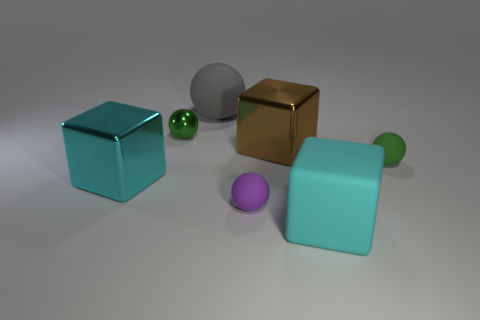There is another cyan thing that is the same shape as the big cyan matte thing; what material is it?
Make the answer very short. Metal. Is the shape of the cyan metallic thing the same as the gray object?
Ensure brevity in your answer.  No. Is there a tiny blue sphere that has the same material as the large brown block?
Ensure brevity in your answer.  No. Are there any big gray balls that are in front of the tiny rubber ball that is in front of the green matte thing?
Provide a succinct answer. No. There is a brown metal block to the right of the metallic ball; does it have the same size as the tiny metal sphere?
Give a very brief answer. No. What size is the green metallic thing?
Offer a very short reply. Small. Is there a small shiny thing of the same color as the small shiny ball?
Provide a succinct answer. No. How many small objects are purple matte things or spheres?
Offer a very short reply. 3. There is a sphere that is both in front of the tiny shiny thing and on the left side of the small green matte ball; what size is it?
Give a very brief answer. Small. There is a cyan metallic block; what number of big cyan metal things are to the right of it?
Provide a succinct answer. 0. 